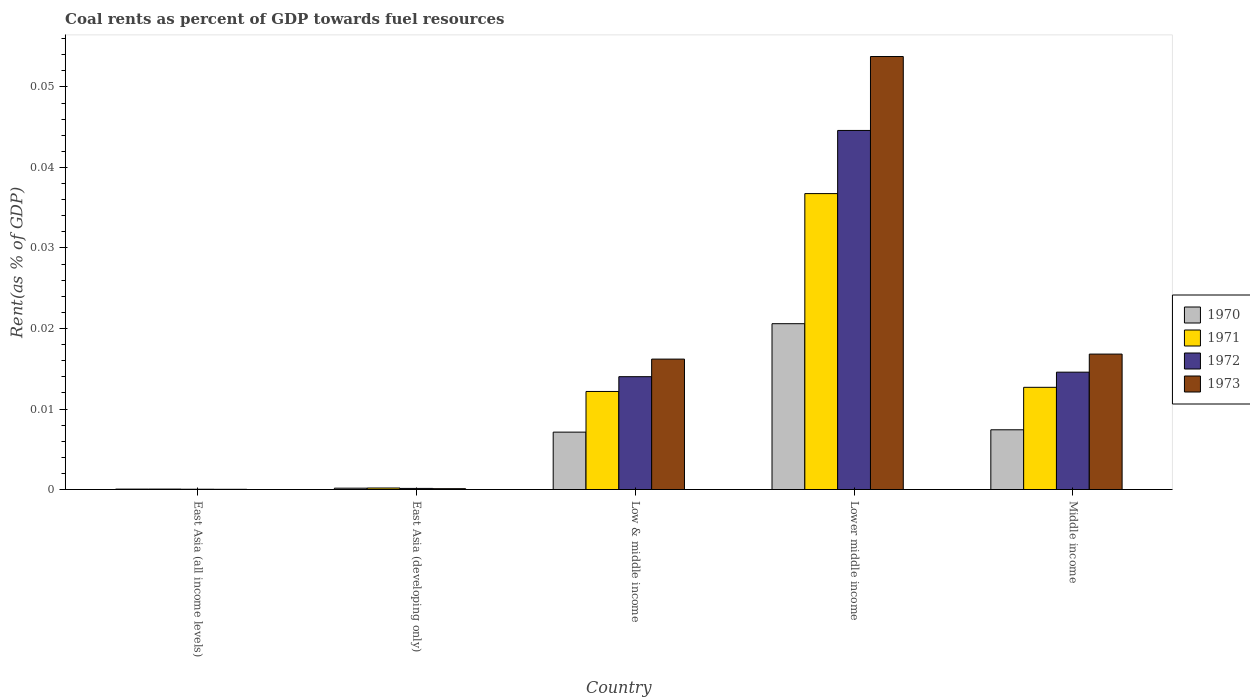How many groups of bars are there?
Your answer should be very brief. 5. Are the number of bars on each tick of the X-axis equal?
Ensure brevity in your answer.  Yes. How many bars are there on the 2nd tick from the left?
Your response must be concise. 4. How many bars are there on the 4th tick from the right?
Provide a short and direct response. 4. What is the label of the 4th group of bars from the left?
Keep it short and to the point. Lower middle income. What is the coal rent in 1970 in Low & middle income?
Keep it short and to the point. 0.01. Across all countries, what is the maximum coal rent in 1973?
Offer a terse response. 0.05. Across all countries, what is the minimum coal rent in 1972?
Give a very brief answer. 3.67730514806032e-5. In which country was the coal rent in 1970 maximum?
Offer a very short reply. Lower middle income. In which country was the coal rent in 1973 minimum?
Your answer should be compact. East Asia (all income levels). What is the total coal rent in 1970 in the graph?
Your answer should be very brief. 0.04. What is the difference between the coal rent in 1973 in Lower middle income and that in Middle income?
Give a very brief answer. 0.04. What is the difference between the coal rent in 1971 in Low & middle income and the coal rent in 1970 in Lower middle income?
Your answer should be very brief. -0.01. What is the average coal rent in 1970 per country?
Your answer should be very brief. 0.01. What is the difference between the coal rent of/in 1973 and coal rent of/in 1971 in Low & middle income?
Your answer should be very brief. 0. In how many countries, is the coal rent in 1971 greater than 0.052000000000000005 %?
Offer a terse response. 0. What is the ratio of the coal rent in 1973 in East Asia (developing only) to that in Lower middle income?
Offer a terse response. 0. What is the difference between the highest and the second highest coal rent in 1971?
Offer a terse response. 0.02. What is the difference between the highest and the lowest coal rent in 1971?
Offer a very short reply. 0.04. Is the sum of the coal rent in 1972 in Lower middle income and Middle income greater than the maximum coal rent in 1970 across all countries?
Provide a short and direct response. Yes. Is it the case that in every country, the sum of the coal rent in 1970 and coal rent in 1971 is greater than the sum of coal rent in 1972 and coal rent in 1973?
Ensure brevity in your answer.  No. Is it the case that in every country, the sum of the coal rent in 1973 and coal rent in 1970 is greater than the coal rent in 1971?
Provide a succinct answer. Yes. How many countries are there in the graph?
Your answer should be compact. 5. What is the difference between two consecutive major ticks on the Y-axis?
Make the answer very short. 0.01. Does the graph contain grids?
Your response must be concise. No. How are the legend labels stacked?
Ensure brevity in your answer.  Vertical. What is the title of the graph?
Make the answer very short. Coal rents as percent of GDP towards fuel resources. Does "1996" appear as one of the legend labels in the graph?
Your answer should be compact. No. What is the label or title of the X-axis?
Provide a short and direct response. Country. What is the label or title of the Y-axis?
Offer a terse response. Rent(as % of GDP). What is the Rent(as % of GDP) in 1970 in East Asia (all income levels)?
Your answer should be very brief. 5.1314079013758e-5. What is the Rent(as % of GDP) in 1971 in East Asia (all income levels)?
Your response must be concise. 5.470114168356261e-5. What is the Rent(as % of GDP) in 1972 in East Asia (all income levels)?
Your response must be concise. 3.67730514806032e-5. What is the Rent(as % of GDP) of 1973 in East Asia (all income levels)?
Keep it short and to the point. 2.64171247686014e-5. What is the Rent(as % of GDP) in 1970 in East Asia (developing only)?
Your response must be concise. 0. What is the Rent(as % of GDP) in 1971 in East Asia (developing only)?
Offer a terse response. 0. What is the Rent(as % of GDP) in 1972 in East Asia (developing only)?
Ensure brevity in your answer.  0. What is the Rent(as % of GDP) in 1973 in East Asia (developing only)?
Ensure brevity in your answer.  0. What is the Rent(as % of GDP) in 1970 in Low & middle income?
Your answer should be compact. 0.01. What is the Rent(as % of GDP) of 1971 in Low & middle income?
Your answer should be compact. 0.01. What is the Rent(as % of GDP) of 1972 in Low & middle income?
Your response must be concise. 0.01. What is the Rent(as % of GDP) of 1973 in Low & middle income?
Your answer should be compact. 0.02. What is the Rent(as % of GDP) in 1970 in Lower middle income?
Keep it short and to the point. 0.02. What is the Rent(as % of GDP) in 1971 in Lower middle income?
Your answer should be compact. 0.04. What is the Rent(as % of GDP) in 1972 in Lower middle income?
Offer a terse response. 0.04. What is the Rent(as % of GDP) of 1973 in Lower middle income?
Keep it short and to the point. 0.05. What is the Rent(as % of GDP) in 1970 in Middle income?
Provide a short and direct response. 0.01. What is the Rent(as % of GDP) in 1971 in Middle income?
Ensure brevity in your answer.  0.01. What is the Rent(as % of GDP) in 1972 in Middle income?
Provide a short and direct response. 0.01. What is the Rent(as % of GDP) in 1973 in Middle income?
Make the answer very short. 0.02. Across all countries, what is the maximum Rent(as % of GDP) in 1970?
Keep it short and to the point. 0.02. Across all countries, what is the maximum Rent(as % of GDP) in 1971?
Provide a short and direct response. 0.04. Across all countries, what is the maximum Rent(as % of GDP) in 1972?
Make the answer very short. 0.04. Across all countries, what is the maximum Rent(as % of GDP) of 1973?
Your answer should be compact. 0.05. Across all countries, what is the minimum Rent(as % of GDP) of 1970?
Your response must be concise. 5.1314079013758e-5. Across all countries, what is the minimum Rent(as % of GDP) in 1971?
Your answer should be very brief. 5.470114168356261e-5. Across all countries, what is the minimum Rent(as % of GDP) in 1972?
Offer a terse response. 3.67730514806032e-5. Across all countries, what is the minimum Rent(as % of GDP) in 1973?
Provide a short and direct response. 2.64171247686014e-5. What is the total Rent(as % of GDP) in 1970 in the graph?
Give a very brief answer. 0.04. What is the total Rent(as % of GDP) of 1971 in the graph?
Give a very brief answer. 0.06. What is the total Rent(as % of GDP) in 1972 in the graph?
Your answer should be very brief. 0.07. What is the total Rent(as % of GDP) of 1973 in the graph?
Provide a succinct answer. 0.09. What is the difference between the Rent(as % of GDP) in 1970 in East Asia (all income levels) and that in East Asia (developing only)?
Offer a terse response. -0. What is the difference between the Rent(as % of GDP) in 1971 in East Asia (all income levels) and that in East Asia (developing only)?
Give a very brief answer. -0. What is the difference between the Rent(as % of GDP) in 1972 in East Asia (all income levels) and that in East Asia (developing only)?
Make the answer very short. -0. What is the difference between the Rent(as % of GDP) of 1973 in East Asia (all income levels) and that in East Asia (developing only)?
Offer a terse response. -0. What is the difference between the Rent(as % of GDP) of 1970 in East Asia (all income levels) and that in Low & middle income?
Give a very brief answer. -0.01. What is the difference between the Rent(as % of GDP) of 1971 in East Asia (all income levels) and that in Low & middle income?
Your answer should be compact. -0.01. What is the difference between the Rent(as % of GDP) of 1972 in East Asia (all income levels) and that in Low & middle income?
Your answer should be compact. -0.01. What is the difference between the Rent(as % of GDP) of 1973 in East Asia (all income levels) and that in Low & middle income?
Keep it short and to the point. -0.02. What is the difference between the Rent(as % of GDP) of 1970 in East Asia (all income levels) and that in Lower middle income?
Offer a terse response. -0.02. What is the difference between the Rent(as % of GDP) of 1971 in East Asia (all income levels) and that in Lower middle income?
Keep it short and to the point. -0.04. What is the difference between the Rent(as % of GDP) in 1972 in East Asia (all income levels) and that in Lower middle income?
Provide a short and direct response. -0.04. What is the difference between the Rent(as % of GDP) of 1973 in East Asia (all income levels) and that in Lower middle income?
Make the answer very short. -0.05. What is the difference between the Rent(as % of GDP) in 1970 in East Asia (all income levels) and that in Middle income?
Your answer should be compact. -0.01. What is the difference between the Rent(as % of GDP) in 1971 in East Asia (all income levels) and that in Middle income?
Offer a very short reply. -0.01. What is the difference between the Rent(as % of GDP) in 1972 in East Asia (all income levels) and that in Middle income?
Keep it short and to the point. -0.01. What is the difference between the Rent(as % of GDP) in 1973 in East Asia (all income levels) and that in Middle income?
Make the answer very short. -0.02. What is the difference between the Rent(as % of GDP) in 1970 in East Asia (developing only) and that in Low & middle income?
Make the answer very short. -0.01. What is the difference between the Rent(as % of GDP) in 1971 in East Asia (developing only) and that in Low & middle income?
Ensure brevity in your answer.  -0.01. What is the difference between the Rent(as % of GDP) in 1972 in East Asia (developing only) and that in Low & middle income?
Your answer should be very brief. -0.01. What is the difference between the Rent(as % of GDP) of 1973 in East Asia (developing only) and that in Low & middle income?
Make the answer very short. -0.02. What is the difference between the Rent(as % of GDP) of 1970 in East Asia (developing only) and that in Lower middle income?
Offer a very short reply. -0.02. What is the difference between the Rent(as % of GDP) of 1971 in East Asia (developing only) and that in Lower middle income?
Your response must be concise. -0.04. What is the difference between the Rent(as % of GDP) of 1972 in East Asia (developing only) and that in Lower middle income?
Offer a very short reply. -0.04. What is the difference between the Rent(as % of GDP) in 1973 in East Asia (developing only) and that in Lower middle income?
Your response must be concise. -0.05. What is the difference between the Rent(as % of GDP) in 1970 in East Asia (developing only) and that in Middle income?
Give a very brief answer. -0.01. What is the difference between the Rent(as % of GDP) in 1971 in East Asia (developing only) and that in Middle income?
Give a very brief answer. -0.01. What is the difference between the Rent(as % of GDP) of 1972 in East Asia (developing only) and that in Middle income?
Your response must be concise. -0.01. What is the difference between the Rent(as % of GDP) in 1973 in East Asia (developing only) and that in Middle income?
Keep it short and to the point. -0.02. What is the difference between the Rent(as % of GDP) of 1970 in Low & middle income and that in Lower middle income?
Make the answer very short. -0.01. What is the difference between the Rent(as % of GDP) in 1971 in Low & middle income and that in Lower middle income?
Give a very brief answer. -0.02. What is the difference between the Rent(as % of GDP) of 1972 in Low & middle income and that in Lower middle income?
Your answer should be compact. -0.03. What is the difference between the Rent(as % of GDP) of 1973 in Low & middle income and that in Lower middle income?
Give a very brief answer. -0.04. What is the difference between the Rent(as % of GDP) in 1970 in Low & middle income and that in Middle income?
Offer a terse response. -0. What is the difference between the Rent(as % of GDP) of 1971 in Low & middle income and that in Middle income?
Give a very brief answer. -0. What is the difference between the Rent(as % of GDP) of 1972 in Low & middle income and that in Middle income?
Your answer should be very brief. -0. What is the difference between the Rent(as % of GDP) in 1973 in Low & middle income and that in Middle income?
Ensure brevity in your answer.  -0. What is the difference between the Rent(as % of GDP) in 1970 in Lower middle income and that in Middle income?
Offer a terse response. 0.01. What is the difference between the Rent(as % of GDP) of 1971 in Lower middle income and that in Middle income?
Your response must be concise. 0.02. What is the difference between the Rent(as % of GDP) in 1973 in Lower middle income and that in Middle income?
Ensure brevity in your answer.  0.04. What is the difference between the Rent(as % of GDP) of 1970 in East Asia (all income levels) and the Rent(as % of GDP) of 1971 in East Asia (developing only)?
Your response must be concise. -0. What is the difference between the Rent(as % of GDP) in 1970 in East Asia (all income levels) and the Rent(as % of GDP) in 1972 in East Asia (developing only)?
Keep it short and to the point. -0. What is the difference between the Rent(as % of GDP) in 1970 in East Asia (all income levels) and the Rent(as % of GDP) in 1973 in East Asia (developing only)?
Offer a terse response. -0. What is the difference between the Rent(as % of GDP) in 1971 in East Asia (all income levels) and the Rent(as % of GDP) in 1972 in East Asia (developing only)?
Offer a very short reply. -0. What is the difference between the Rent(as % of GDP) in 1972 in East Asia (all income levels) and the Rent(as % of GDP) in 1973 in East Asia (developing only)?
Provide a short and direct response. -0. What is the difference between the Rent(as % of GDP) in 1970 in East Asia (all income levels) and the Rent(as % of GDP) in 1971 in Low & middle income?
Give a very brief answer. -0.01. What is the difference between the Rent(as % of GDP) in 1970 in East Asia (all income levels) and the Rent(as % of GDP) in 1972 in Low & middle income?
Ensure brevity in your answer.  -0.01. What is the difference between the Rent(as % of GDP) of 1970 in East Asia (all income levels) and the Rent(as % of GDP) of 1973 in Low & middle income?
Provide a short and direct response. -0.02. What is the difference between the Rent(as % of GDP) of 1971 in East Asia (all income levels) and the Rent(as % of GDP) of 1972 in Low & middle income?
Your answer should be compact. -0.01. What is the difference between the Rent(as % of GDP) in 1971 in East Asia (all income levels) and the Rent(as % of GDP) in 1973 in Low & middle income?
Offer a terse response. -0.02. What is the difference between the Rent(as % of GDP) in 1972 in East Asia (all income levels) and the Rent(as % of GDP) in 1973 in Low & middle income?
Offer a terse response. -0.02. What is the difference between the Rent(as % of GDP) of 1970 in East Asia (all income levels) and the Rent(as % of GDP) of 1971 in Lower middle income?
Your answer should be compact. -0.04. What is the difference between the Rent(as % of GDP) of 1970 in East Asia (all income levels) and the Rent(as % of GDP) of 1972 in Lower middle income?
Ensure brevity in your answer.  -0.04. What is the difference between the Rent(as % of GDP) in 1970 in East Asia (all income levels) and the Rent(as % of GDP) in 1973 in Lower middle income?
Provide a succinct answer. -0.05. What is the difference between the Rent(as % of GDP) of 1971 in East Asia (all income levels) and the Rent(as % of GDP) of 1972 in Lower middle income?
Provide a short and direct response. -0.04. What is the difference between the Rent(as % of GDP) in 1971 in East Asia (all income levels) and the Rent(as % of GDP) in 1973 in Lower middle income?
Your answer should be compact. -0.05. What is the difference between the Rent(as % of GDP) in 1972 in East Asia (all income levels) and the Rent(as % of GDP) in 1973 in Lower middle income?
Provide a succinct answer. -0.05. What is the difference between the Rent(as % of GDP) in 1970 in East Asia (all income levels) and the Rent(as % of GDP) in 1971 in Middle income?
Your answer should be very brief. -0.01. What is the difference between the Rent(as % of GDP) in 1970 in East Asia (all income levels) and the Rent(as % of GDP) in 1972 in Middle income?
Give a very brief answer. -0.01. What is the difference between the Rent(as % of GDP) in 1970 in East Asia (all income levels) and the Rent(as % of GDP) in 1973 in Middle income?
Your response must be concise. -0.02. What is the difference between the Rent(as % of GDP) of 1971 in East Asia (all income levels) and the Rent(as % of GDP) of 1972 in Middle income?
Offer a terse response. -0.01. What is the difference between the Rent(as % of GDP) in 1971 in East Asia (all income levels) and the Rent(as % of GDP) in 1973 in Middle income?
Provide a short and direct response. -0.02. What is the difference between the Rent(as % of GDP) in 1972 in East Asia (all income levels) and the Rent(as % of GDP) in 1973 in Middle income?
Ensure brevity in your answer.  -0.02. What is the difference between the Rent(as % of GDP) of 1970 in East Asia (developing only) and the Rent(as % of GDP) of 1971 in Low & middle income?
Keep it short and to the point. -0.01. What is the difference between the Rent(as % of GDP) in 1970 in East Asia (developing only) and the Rent(as % of GDP) in 1972 in Low & middle income?
Keep it short and to the point. -0.01. What is the difference between the Rent(as % of GDP) in 1970 in East Asia (developing only) and the Rent(as % of GDP) in 1973 in Low & middle income?
Offer a terse response. -0.02. What is the difference between the Rent(as % of GDP) of 1971 in East Asia (developing only) and the Rent(as % of GDP) of 1972 in Low & middle income?
Offer a very short reply. -0.01. What is the difference between the Rent(as % of GDP) in 1971 in East Asia (developing only) and the Rent(as % of GDP) in 1973 in Low & middle income?
Provide a short and direct response. -0.02. What is the difference between the Rent(as % of GDP) in 1972 in East Asia (developing only) and the Rent(as % of GDP) in 1973 in Low & middle income?
Provide a succinct answer. -0.02. What is the difference between the Rent(as % of GDP) of 1970 in East Asia (developing only) and the Rent(as % of GDP) of 1971 in Lower middle income?
Make the answer very short. -0.04. What is the difference between the Rent(as % of GDP) in 1970 in East Asia (developing only) and the Rent(as % of GDP) in 1972 in Lower middle income?
Offer a terse response. -0.04. What is the difference between the Rent(as % of GDP) in 1970 in East Asia (developing only) and the Rent(as % of GDP) in 1973 in Lower middle income?
Your answer should be compact. -0.05. What is the difference between the Rent(as % of GDP) in 1971 in East Asia (developing only) and the Rent(as % of GDP) in 1972 in Lower middle income?
Ensure brevity in your answer.  -0.04. What is the difference between the Rent(as % of GDP) in 1971 in East Asia (developing only) and the Rent(as % of GDP) in 1973 in Lower middle income?
Give a very brief answer. -0.05. What is the difference between the Rent(as % of GDP) in 1972 in East Asia (developing only) and the Rent(as % of GDP) in 1973 in Lower middle income?
Provide a short and direct response. -0.05. What is the difference between the Rent(as % of GDP) in 1970 in East Asia (developing only) and the Rent(as % of GDP) in 1971 in Middle income?
Your answer should be compact. -0.01. What is the difference between the Rent(as % of GDP) in 1970 in East Asia (developing only) and the Rent(as % of GDP) in 1972 in Middle income?
Your response must be concise. -0.01. What is the difference between the Rent(as % of GDP) in 1970 in East Asia (developing only) and the Rent(as % of GDP) in 1973 in Middle income?
Make the answer very short. -0.02. What is the difference between the Rent(as % of GDP) in 1971 in East Asia (developing only) and the Rent(as % of GDP) in 1972 in Middle income?
Ensure brevity in your answer.  -0.01. What is the difference between the Rent(as % of GDP) of 1971 in East Asia (developing only) and the Rent(as % of GDP) of 1973 in Middle income?
Offer a terse response. -0.02. What is the difference between the Rent(as % of GDP) of 1972 in East Asia (developing only) and the Rent(as % of GDP) of 1973 in Middle income?
Give a very brief answer. -0.02. What is the difference between the Rent(as % of GDP) of 1970 in Low & middle income and the Rent(as % of GDP) of 1971 in Lower middle income?
Your answer should be compact. -0.03. What is the difference between the Rent(as % of GDP) in 1970 in Low & middle income and the Rent(as % of GDP) in 1972 in Lower middle income?
Offer a terse response. -0.04. What is the difference between the Rent(as % of GDP) in 1970 in Low & middle income and the Rent(as % of GDP) in 1973 in Lower middle income?
Make the answer very short. -0.05. What is the difference between the Rent(as % of GDP) of 1971 in Low & middle income and the Rent(as % of GDP) of 1972 in Lower middle income?
Offer a terse response. -0.03. What is the difference between the Rent(as % of GDP) in 1971 in Low & middle income and the Rent(as % of GDP) in 1973 in Lower middle income?
Give a very brief answer. -0.04. What is the difference between the Rent(as % of GDP) in 1972 in Low & middle income and the Rent(as % of GDP) in 1973 in Lower middle income?
Your response must be concise. -0.04. What is the difference between the Rent(as % of GDP) of 1970 in Low & middle income and the Rent(as % of GDP) of 1971 in Middle income?
Keep it short and to the point. -0.01. What is the difference between the Rent(as % of GDP) in 1970 in Low & middle income and the Rent(as % of GDP) in 1972 in Middle income?
Offer a terse response. -0.01. What is the difference between the Rent(as % of GDP) in 1970 in Low & middle income and the Rent(as % of GDP) in 1973 in Middle income?
Provide a succinct answer. -0.01. What is the difference between the Rent(as % of GDP) in 1971 in Low & middle income and the Rent(as % of GDP) in 1972 in Middle income?
Your answer should be very brief. -0. What is the difference between the Rent(as % of GDP) of 1971 in Low & middle income and the Rent(as % of GDP) of 1973 in Middle income?
Give a very brief answer. -0. What is the difference between the Rent(as % of GDP) of 1972 in Low & middle income and the Rent(as % of GDP) of 1973 in Middle income?
Offer a very short reply. -0. What is the difference between the Rent(as % of GDP) in 1970 in Lower middle income and the Rent(as % of GDP) in 1971 in Middle income?
Ensure brevity in your answer.  0.01. What is the difference between the Rent(as % of GDP) in 1970 in Lower middle income and the Rent(as % of GDP) in 1972 in Middle income?
Your answer should be very brief. 0.01. What is the difference between the Rent(as % of GDP) of 1970 in Lower middle income and the Rent(as % of GDP) of 1973 in Middle income?
Provide a succinct answer. 0. What is the difference between the Rent(as % of GDP) in 1971 in Lower middle income and the Rent(as % of GDP) in 1972 in Middle income?
Make the answer very short. 0.02. What is the difference between the Rent(as % of GDP) in 1971 in Lower middle income and the Rent(as % of GDP) in 1973 in Middle income?
Your answer should be very brief. 0.02. What is the difference between the Rent(as % of GDP) of 1972 in Lower middle income and the Rent(as % of GDP) of 1973 in Middle income?
Give a very brief answer. 0.03. What is the average Rent(as % of GDP) of 1970 per country?
Make the answer very short. 0.01. What is the average Rent(as % of GDP) in 1971 per country?
Your response must be concise. 0.01. What is the average Rent(as % of GDP) in 1972 per country?
Offer a terse response. 0.01. What is the average Rent(as % of GDP) in 1973 per country?
Offer a very short reply. 0.02. What is the difference between the Rent(as % of GDP) of 1970 and Rent(as % of GDP) of 1971 in East Asia (all income levels)?
Offer a terse response. -0. What is the difference between the Rent(as % of GDP) in 1970 and Rent(as % of GDP) in 1972 in East Asia (all income levels)?
Offer a terse response. 0. What is the difference between the Rent(as % of GDP) in 1972 and Rent(as % of GDP) in 1973 in East Asia (all income levels)?
Provide a short and direct response. 0. What is the difference between the Rent(as % of GDP) of 1970 and Rent(as % of GDP) of 1971 in East Asia (developing only)?
Provide a short and direct response. -0. What is the difference between the Rent(as % of GDP) in 1972 and Rent(as % of GDP) in 1973 in East Asia (developing only)?
Keep it short and to the point. 0. What is the difference between the Rent(as % of GDP) in 1970 and Rent(as % of GDP) in 1971 in Low & middle income?
Your answer should be compact. -0.01. What is the difference between the Rent(as % of GDP) in 1970 and Rent(as % of GDP) in 1972 in Low & middle income?
Your answer should be very brief. -0.01. What is the difference between the Rent(as % of GDP) of 1970 and Rent(as % of GDP) of 1973 in Low & middle income?
Your answer should be very brief. -0.01. What is the difference between the Rent(as % of GDP) of 1971 and Rent(as % of GDP) of 1972 in Low & middle income?
Provide a short and direct response. -0. What is the difference between the Rent(as % of GDP) in 1971 and Rent(as % of GDP) in 1973 in Low & middle income?
Offer a terse response. -0. What is the difference between the Rent(as % of GDP) in 1972 and Rent(as % of GDP) in 1973 in Low & middle income?
Your answer should be very brief. -0. What is the difference between the Rent(as % of GDP) in 1970 and Rent(as % of GDP) in 1971 in Lower middle income?
Your response must be concise. -0.02. What is the difference between the Rent(as % of GDP) of 1970 and Rent(as % of GDP) of 1972 in Lower middle income?
Your answer should be compact. -0.02. What is the difference between the Rent(as % of GDP) of 1970 and Rent(as % of GDP) of 1973 in Lower middle income?
Ensure brevity in your answer.  -0.03. What is the difference between the Rent(as % of GDP) in 1971 and Rent(as % of GDP) in 1972 in Lower middle income?
Ensure brevity in your answer.  -0.01. What is the difference between the Rent(as % of GDP) in 1971 and Rent(as % of GDP) in 1973 in Lower middle income?
Make the answer very short. -0.02. What is the difference between the Rent(as % of GDP) of 1972 and Rent(as % of GDP) of 1973 in Lower middle income?
Make the answer very short. -0.01. What is the difference between the Rent(as % of GDP) in 1970 and Rent(as % of GDP) in 1971 in Middle income?
Offer a very short reply. -0.01. What is the difference between the Rent(as % of GDP) of 1970 and Rent(as % of GDP) of 1972 in Middle income?
Give a very brief answer. -0.01. What is the difference between the Rent(as % of GDP) in 1970 and Rent(as % of GDP) in 1973 in Middle income?
Your answer should be compact. -0.01. What is the difference between the Rent(as % of GDP) of 1971 and Rent(as % of GDP) of 1972 in Middle income?
Provide a succinct answer. -0. What is the difference between the Rent(as % of GDP) in 1971 and Rent(as % of GDP) in 1973 in Middle income?
Offer a terse response. -0. What is the difference between the Rent(as % of GDP) of 1972 and Rent(as % of GDP) of 1973 in Middle income?
Provide a short and direct response. -0. What is the ratio of the Rent(as % of GDP) of 1970 in East Asia (all income levels) to that in East Asia (developing only)?
Make the answer very short. 0.31. What is the ratio of the Rent(as % of GDP) in 1971 in East Asia (all income levels) to that in East Asia (developing only)?
Offer a terse response. 0.29. What is the ratio of the Rent(as % of GDP) in 1972 in East Asia (all income levels) to that in East Asia (developing only)?
Offer a terse response. 0.27. What is the ratio of the Rent(as % of GDP) in 1973 in East Asia (all income levels) to that in East Asia (developing only)?
Keep it short and to the point. 0.26. What is the ratio of the Rent(as % of GDP) in 1970 in East Asia (all income levels) to that in Low & middle income?
Your response must be concise. 0.01. What is the ratio of the Rent(as % of GDP) of 1971 in East Asia (all income levels) to that in Low & middle income?
Offer a terse response. 0. What is the ratio of the Rent(as % of GDP) in 1972 in East Asia (all income levels) to that in Low & middle income?
Your response must be concise. 0. What is the ratio of the Rent(as % of GDP) of 1973 in East Asia (all income levels) to that in Low & middle income?
Provide a short and direct response. 0. What is the ratio of the Rent(as % of GDP) of 1970 in East Asia (all income levels) to that in Lower middle income?
Offer a terse response. 0. What is the ratio of the Rent(as % of GDP) in 1971 in East Asia (all income levels) to that in Lower middle income?
Keep it short and to the point. 0. What is the ratio of the Rent(as % of GDP) in 1972 in East Asia (all income levels) to that in Lower middle income?
Offer a terse response. 0. What is the ratio of the Rent(as % of GDP) in 1973 in East Asia (all income levels) to that in Lower middle income?
Provide a short and direct response. 0. What is the ratio of the Rent(as % of GDP) of 1970 in East Asia (all income levels) to that in Middle income?
Your response must be concise. 0.01. What is the ratio of the Rent(as % of GDP) in 1971 in East Asia (all income levels) to that in Middle income?
Ensure brevity in your answer.  0. What is the ratio of the Rent(as % of GDP) of 1972 in East Asia (all income levels) to that in Middle income?
Ensure brevity in your answer.  0. What is the ratio of the Rent(as % of GDP) in 1973 in East Asia (all income levels) to that in Middle income?
Your answer should be compact. 0. What is the ratio of the Rent(as % of GDP) of 1970 in East Asia (developing only) to that in Low & middle income?
Keep it short and to the point. 0.02. What is the ratio of the Rent(as % of GDP) in 1971 in East Asia (developing only) to that in Low & middle income?
Your answer should be very brief. 0.02. What is the ratio of the Rent(as % of GDP) in 1972 in East Asia (developing only) to that in Low & middle income?
Make the answer very short. 0.01. What is the ratio of the Rent(as % of GDP) in 1973 in East Asia (developing only) to that in Low & middle income?
Your answer should be compact. 0.01. What is the ratio of the Rent(as % of GDP) of 1970 in East Asia (developing only) to that in Lower middle income?
Offer a very short reply. 0.01. What is the ratio of the Rent(as % of GDP) in 1971 in East Asia (developing only) to that in Lower middle income?
Ensure brevity in your answer.  0.01. What is the ratio of the Rent(as % of GDP) of 1972 in East Asia (developing only) to that in Lower middle income?
Your answer should be compact. 0. What is the ratio of the Rent(as % of GDP) in 1973 in East Asia (developing only) to that in Lower middle income?
Offer a terse response. 0. What is the ratio of the Rent(as % of GDP) in 1970 in East Asia (developing only) to that in Middle income?
Your response must be concise. 0.02. What is the ratio of the Rent(as % of GDP) in 1971 in East Asia (developing only) to that in Middle income?
Provide a short and direct response. 0.01. What is the ratio of the Rent(as % of GDP) in 1972 in East Asia (developing only) to that in Middle income?
Your response must be concise. 0.01. What is the ratio of the Rent(as % of GDP) in 1973 in East Asia (developing only) to that in Middle income?
Keep it short and to the point. 0.01. What is the ratio of the Rent(as % of GDP) of 1970 in Low & middle income to that in Lower middle income?
Ensure brevity in your answer.  0.35. What is the ratio of the Rent(as % of GDP) in 1971 in Low & middle income to that in Lower middle income?
Your answer should be compact. 0.33. What is the ratio of the Rent(as % of GDP) in 1972 in Low & middle income to that in Lower middle income?
Your answer should be compact. 0.31. What is the ratio of the Rent(as % of GDP) of 1973 in Low & middle income to that in Lower middle income?
Make the answer very short. 0.3. What is the ratio of the Rent(as % of GDP) in 1970 in Low & middle income to that in Middle income?
Your response must be concise. 0.96. What is the ratio of the Rent(as % of GDP) in 1971 in Low & middle income to that in Middle income?
Offer a terse response. 0.96. What is the ratio of the Rent(as % of GDP) of 1972 in Low & middle income to that in Middle income?
Give a very brief answer. 0.96. What is the ratio of the Rent(as % of GDP) of 1973 in Low & middle income to that in Middle income?
Your answer should be very brief. 0.96. What is the ratio of the Rent(as % of GDP) in 1970 in Lower middle income to that in Middle income?
Provide a short and direct response. 2.78. What is the ratio of the Rent(as % of GDP) of 1971 in Lower middle income to that in Middle income?
Provide a succinct answer. 2.9. What is the ratio of the Rent(as % of GDP) of 1972 in Lower middle income to that in Middle income?
Offer a very short reply. 3.06. What is the ratio of the Rent(as % of GDP) of 1973 in Lower middle income to that in Middle income?
Keep it short and to the point. 3.2. What is the difference between the highest and the second highest Rent(as % of GDP) in 1970?
Offer a very short reply. 0.01. What is the difference between the highest and the second highest Rent(as % of GDP) of 1971?
Keep it short and to the point. 0.02. What is the difference between the highest and the second highest Rent(as % of GDP) in 1973?
Provide a short and direct response. 0.04. What is the difference between the highest and the lowest Rent(as % of GDP) in 1970?
Make the answer very short. 0.02. What is the difference between the highest and the lowest Rent(as % of GDP) in 1971?
Ensure brevity in your answer.  0.04. What is the difference between the highest and the lowest Rent(as % of GDP) in 1972?
Your response must be concise. 0.04. What is the difference between the highest and the lowest Rent(as % of GDP) of 1973?
Give a very brief answer. 0.05. 